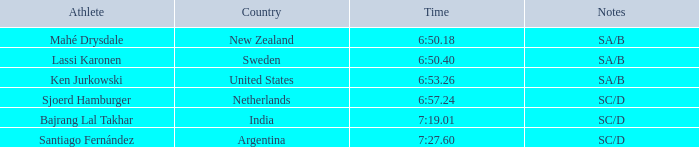40? 2.0. 